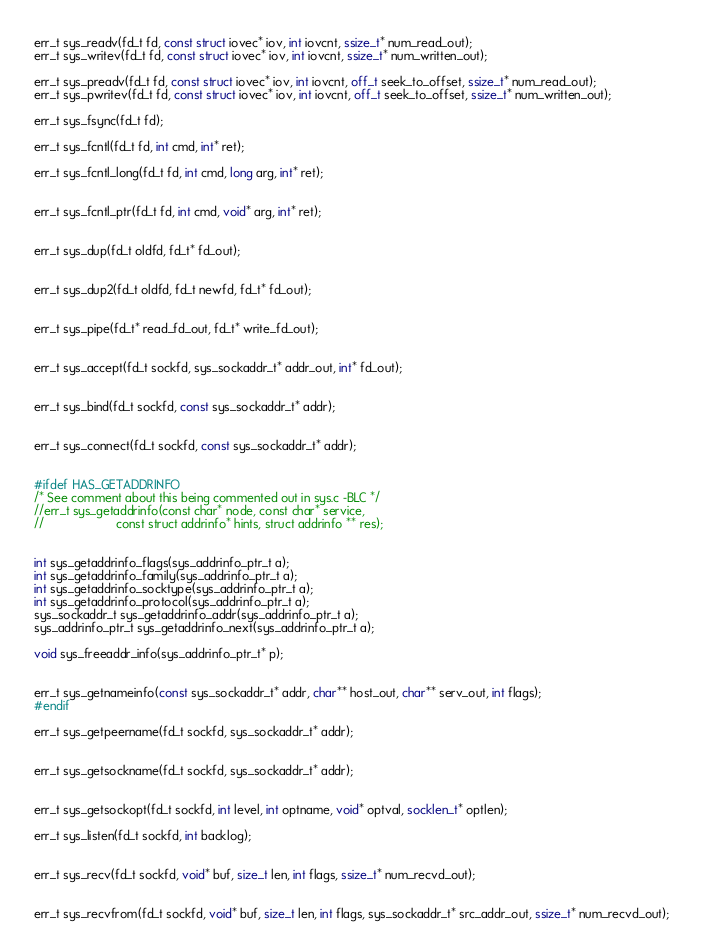<code> <loc_0><loc_0><loc_500><loc_500><_C_>err_t sys_readv(fd_t fd, const struct iovec* iov, int iovcnt, ssize_t* num_read_out);
err_t sys_writev(fd_t fd, const struct iovec* iov, int iovcnt, ssize_t* num_written_out);

err_t sys_preadv(fd_t fd, const struct iovec* iov, int iovcnt, off_t seek_to_offset, ssize_t* num_read_out);
err_t sys_pwritev(fd_t fd, const struct iovec* iov, int iovcnt, off_t seek_to_offset, ssize_t* num_written_out);

err_t sys_fsync(fd_t fd);

err_t sys_fcntl(fd_t fd, int cmd, int* ret);

err_t sys_fcntl_long(fd_t fd, int cmd, long arg, int* ret);


err_t sys_fcntl_ptr(fd_t fd, int cmd, void* arg, int* ret);


err_t sys_dup(fd_t oldfd, fd_t* fd_out);


err_t sys_dup2(fd_t oldfd, fd_t newfd, fd_t* fd_out);


err_t sys_pipe(fd_t* read_fd_out, fd_t* write_fd_out);


err_t sys_accept(fd_t sockfd, sys_sockaddr_t* addr_out, int* fd_out);


err_t sys_bind(fd_t sockfd, const sys_sockaddr_t* addr);


err_t sys_connect(fd_t sockfd, const sys_sockaddr_t* addr);


#ifdef HAS_GETADDRINFO
/* See comment about this being commented out in sys.c -BLC */
//err_t sys_getaddrinfo(const char* node, const char* service,
//                     const struct addrinfo* hints, struct addrinfo ** res);


int sys_getaddrinfo_flags(sys_addrinfo_ptr_t a);
int sys_getaddrinfo_family(sys_addrinfo_ptr_t a);
int sys_getaddrinfo_socktype(sys_addrinfo_ptr_t a);
int sys_getaddrinfo_protocol(sys_addrinfo_ptr_t a);
sys_sockaddr_t sys_getaddrinfo_addr(sys_addrinfo_ptr_t a);
sys_addrinfo_ptr_t sys_getaddrinfo_next(sys_addrinfo_ptr_t a);

void sys_freeaddr_info(sys_addrinfo_ptr_t* p);


err_t sys_getnameinfo(const sys_sockaddr_t* addr, char** host_out, char** serv_out, int flags);
#endif

err_t sys_getpeername(fd_t sockfd, sys_sockaddr_t* addr);


err_t sys_getsockname(fd_t sockfd, sys_sockaddr_t* addr);


err_t sys_getsockopt(fd_t sockfd, int level, int optname, void* optval, socklen_t* optlen);

err_t sys_listen(fd_t sockfd, int backlog);


err_t sys_recv(fd_t sockfd, void* buf, size_t len, int flags, ssize_t* num_recvd_out);


err_t sys_recvfrom(fd_t sockfd, void* buf, size_t len, int flags, sys_sockaddr_t* src_addr_out, ssize_t* num_recvd_out);

</code> 